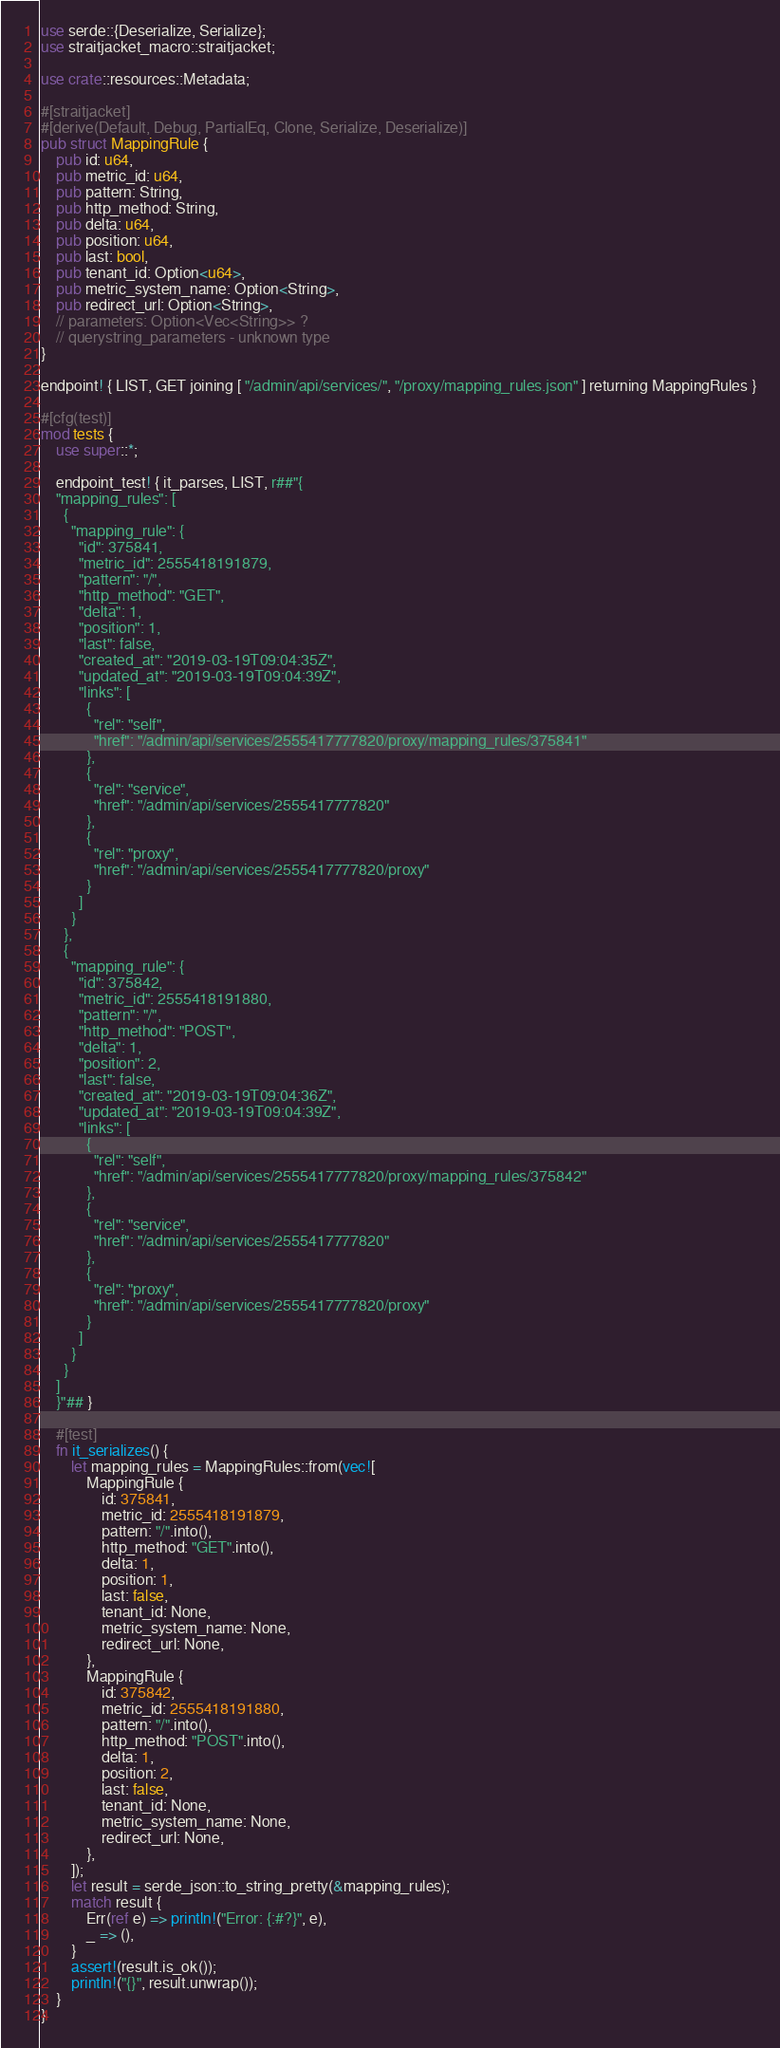Convert code to text. <code><loc_0><loc_0><loc_500><loc_500><_Rust_>use serde::{Deserialize, Serialize};
use straitjacket_macro::straitjacket;

use crate::resources::Metadata;

#[straitjacket]
#[derive(Default, Debug, PartialEq, Clone, Serialize, Deserialize)]
pub struct MappingRule {
    pub id: u64,
    pub metric_id: u64,
    pub pattern: String,
    pub http_method: String,
    pub delta: u64,
    pub position: u64,
    pub last: bool,
    pub tenant_id: Option<u64>,
    pub metric_system_name: Option<String>,
    pub redirect_url: Option<String>,
    // parameters: Option<Vec<String>> ?
    // querystring_parameters - unknown type
}

endpoint! { LIST, GET joining [ "/admin/api/services/", "/proxy/mapping_rules.json" ] returning MappingRules }

#[cfg(test)]
mod tests {
    use super::*;

    endpoint_test! { it_parses, LIST, r##"{
    "mapping_rules": [
      {
        "mapping_rule": {
          "id": 375841,
          "metric_id": 2555418191879,
          "pattern": "/",
          "http_method": "GET",
          "delta": 1,
          "position": 1,
          "last": false,
          "created_at": "2019-03-19T09:04:35Z",
          "updated_at": "2019-03-19T09:04:39Z",
          "links": [
            {
              "rel": "self",
              "href": "/admin/api/services/2555417777820/proxy/mapping_rules/375841"
            },
            {
              "rel": "service",
              "href": "/admin/api/services/2555417777820"
            },
            {
              "rel": "proxy",
              "href": "/admin/api/services/2555417777820/proxy"
            }
          ]
        }
      },
      {
        "mapping_rule": {
          "id": 375842,
          "metric_id": 2555418191880,
          "pattern": "/",
          "http_method": "POST",
          "delta": 1,
          "position": 2,
          "last": false,
          "created_at": "2019-03-19T09:04:36Z",
          "updated_at": "2019-03-19T09:04:39Z",
          "links": [
            {
              "rel": "self",
              "href": "/admin/api/services/2555417777820/proxy/mapping_rules/375842"
            },
            {
              "rel": "service",
              "href": "/admin/api/services/2555417777820"
            },
            {
              "rel": "proxy",
              "href": "/admin/api/services/2555417777820/proxy"
            }
          ]
        }
      }
    ]
    }"## }

    #[test]
    fn it_serializes() {
        let mapping_rules = MappingRules::from(vec![
            MappingRule {
                id: 375841,
                metric_id: 2555418191879,
                pattern: "/".into(),
                http_method: "GET".into(),
                delta: 1,
                position: 1,
                last: false,
                tenant_id: None,
                metric_system_name: None,
                redirect_url: None,
            },
            MappingRule {
                id: 375842,
                metric_id: 2555418191880,
                pattern: "/".into(),
                http_method: "POST".into(),
                delta: 1,
                position: 2,
                last: false,
                tenant_id: None,
                metric_system_name: None,
                redirect_url: None,
            },
        ]);
        let result = serde_json::to_string_pretty(&mapping_rules);
        match result {
            Err(ref e) => println!("Error: {:#?}", e),
            _ => (),
        }
        assert!(result.is_ok());
        println!("{}", result.unwrap());
    }
}
</code> 